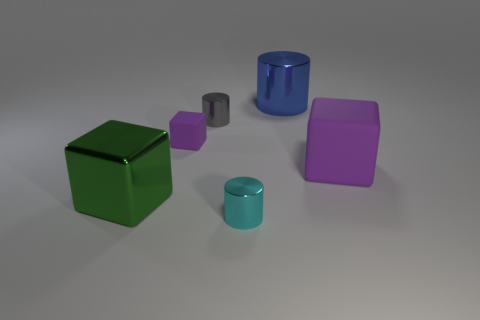Add 3 green cubes. How many objects exist? 9 Subtract all large blue shiny cylinders. How many cylinders are left? 2 Subtract all blue cubes. Subtract all gray cylinders. How many cubes are left? 3 Subtract all blue cylinders. How many purple cubes are left? 2 Subtract all tiny cyan cylinders. Subtract all small purple cubes. How many objects are left? 4 Add 2 cyan metal cylinders. How many cyan metal cylinders are left? 3 Add 6 big blue objects. How many big blue objects exist? 7 Subtract all cyan cylinders. How many cylinders are left? 2 Subtract 2 purple cubes. How many objects are left? 4 Subtract 3 cylinders. How many cylinders are left? 0 